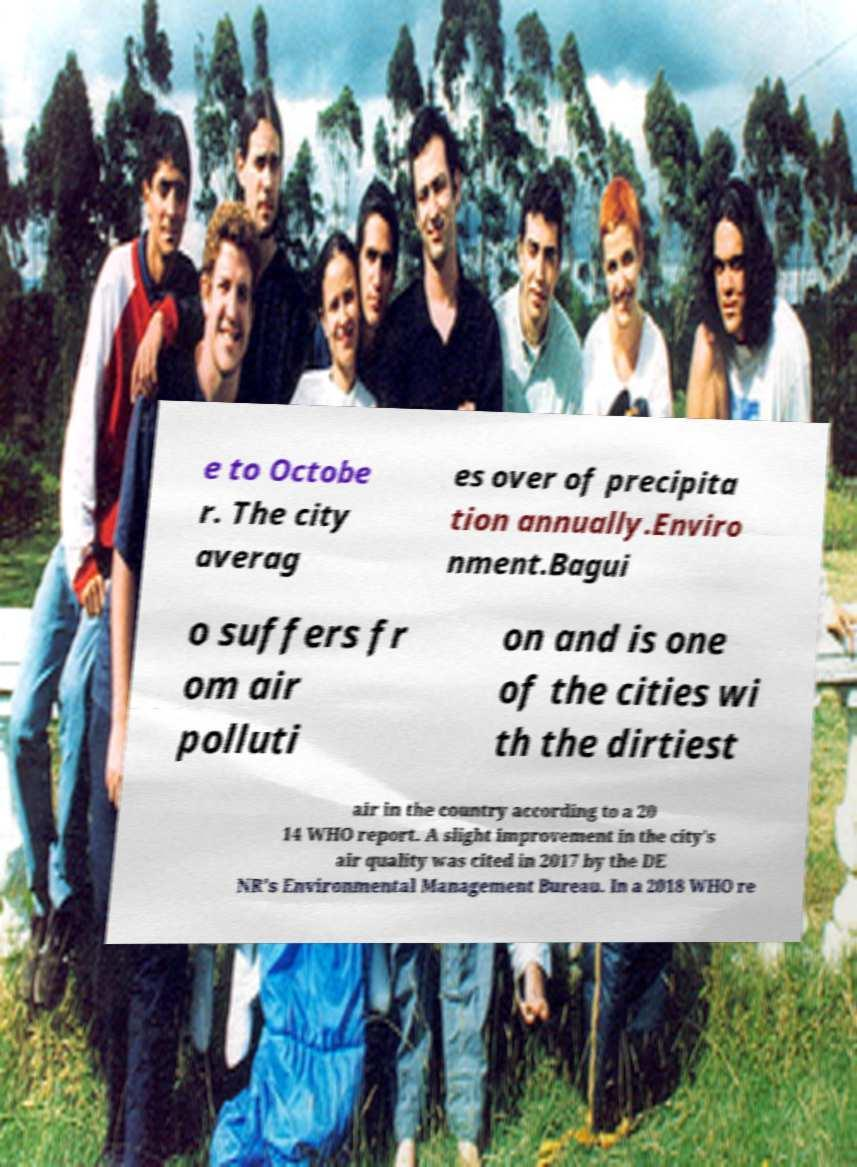Could you extract and type out the text from this image? e to Octobe r. The city averag es over of precipita tion annually.Enviro nment.Bagui o suffers fr om air polluti on and is one of the cities wi th the dirtiest air in the country according to a 20 14 WHO report. A slight improvement in the city's air quality was cited in 2017 by the DE NR's Environmental Management Bureau. In a 2018 WHO re 